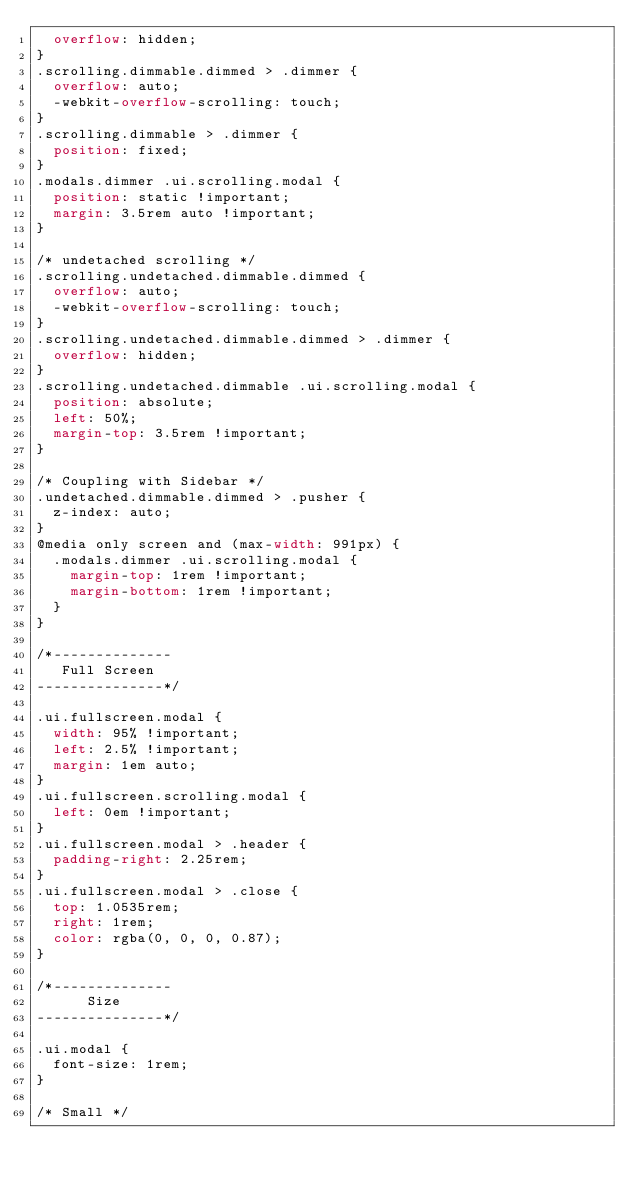<code> <loc_0><loc_0><loc_500><loc_500><_CSS_>  overflow: hidden;
}
.scrolling.dimmable.dimmed > .dimmer {
  overflow: auto;
  -webkit-overflow-scrolling: touch;
}
.scrolling.dimmable > .dimmer {
  position: fixed;
}
.modals.dimmer .ui.scrolling.modal {
  position: static !important;
  margin: 3.5rem auto !important;
}

/* undetached scrolling */
.scrolling.undetached.dimmable.dimmed {
  overflow: auto;
  -webkit-overflow-scrolling: touch;
}
.scrolling.undetached.dimmable.dimmed > .dimmer {
  overflow: hidden;
}
.scrolling.undetached.dimmable .ui.scrolling.modal {
  position: absolute;
  left: 50%;
  margin-top: 3.5rem !important;
}

/* Coupling with Sidebar */
.undetached.dimmable.dimmed > .pusher {
  z-index: auto;
}
@media only screen and (max-width: 991px) {
  .modals.dimmer .ui.scrolling.modal {
    margin-top: 1rem !important;
    margin-bottom: 1rem !important;
  }
}

/*--------------
   Full Screen
---------------*/

.ui.fullscreen.modal {
  width: 95% !important;
  left: 2.5% !important;
  margin: 1em auto;
}
.ui.fullscreen.scrolling.modal {
  left: 0em !important;
}
.ui.fullscreen.modal > .header {
  padding-right: 2.25rem;
}
.ui.fullscreen.modal > .close {
  top: 1.0535rem;
  right: 1rem;
  color: rgba(0, 0, 0, 0.87);
}

/*--------------
      Size
---------------*/

.ui.modal {
  font-size: 1rem;
}

/* Small */</code> 